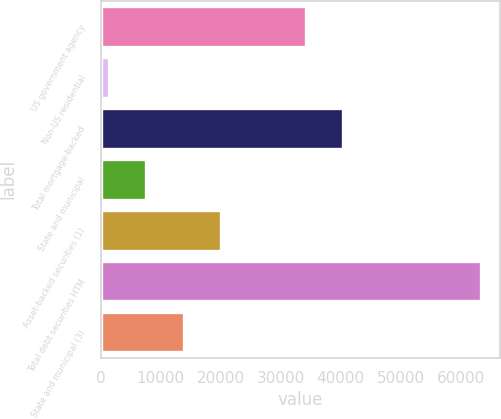<chart> <loc_0><loc_0><loc_500><loc_500><bar_chart><fcel>US government agency<fcel>Non-US residential<fcel>Total mortgage-backed<fcel>State and municipal<fcel>Asset-backed securities (1)<fcel>Total debt securities HTM<fcel>State and municipal (3)<nl><fcel>34239<fcel>1339<fcel>40440.8<fcel>7628<fcel>20031.6<fcel>63357<fcel>13829.8<nl></chart> 